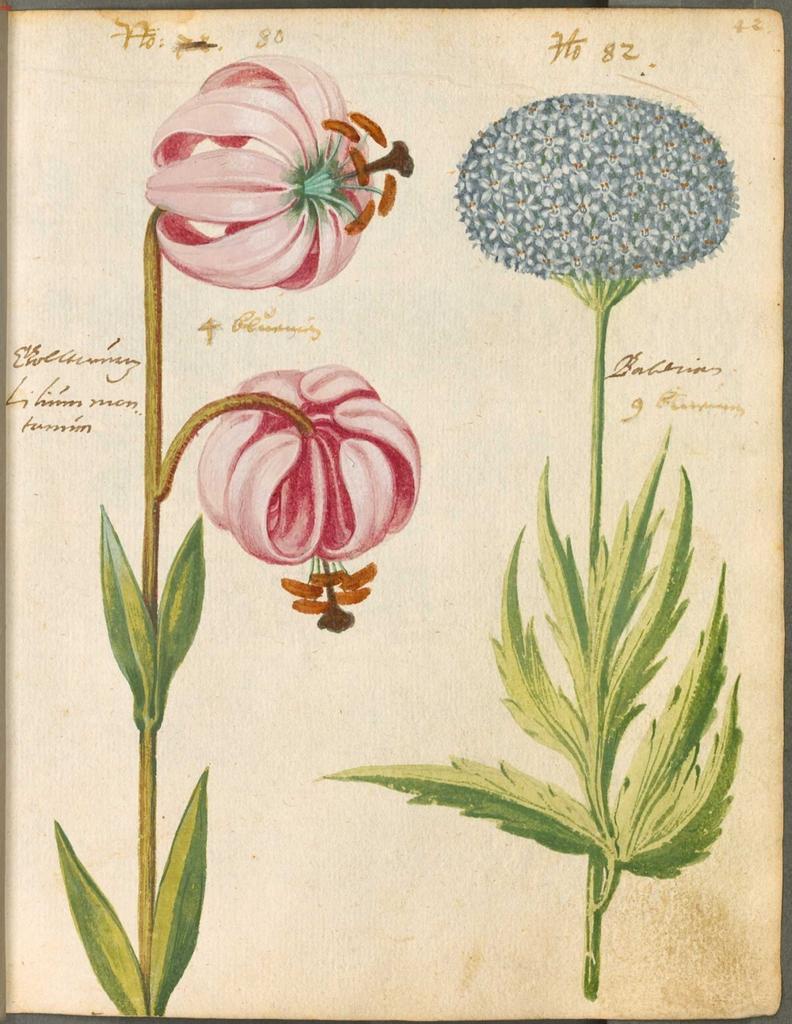Describe this image in one or two sentences. In this picture I can see the depiction of plants and flowers on a paper and I see something is written on it. 